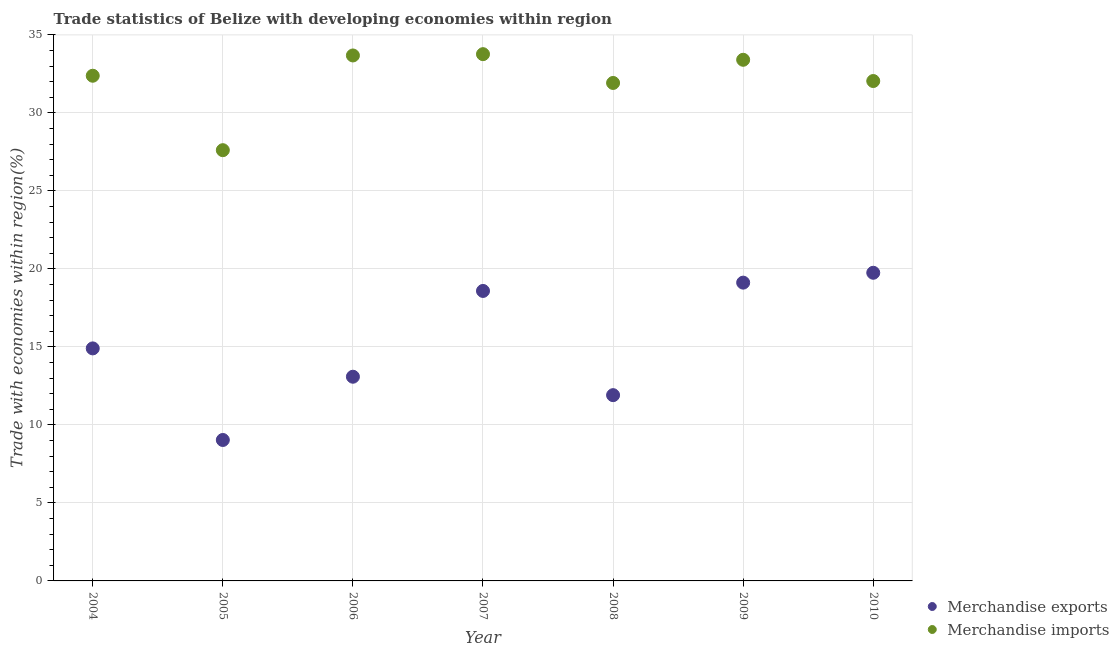What is the merchandise imports in 2009?
Your response must be concise. 33.41. Across all years, what is the maximum merchandise imports?
Provide a succinct answer. 33.77. Across all years, what is the minimum merchandise imports?
Your answer should be compact. 27.61. What is the total merchandise imports in the graph?
Provide a short and direct response. 224.82. What is the difference between the merchandise imports in 2009 and that in 2010?
Your answer should be very brief. 1.36. What is the difference between the merchandise imports in 2007 and the merchandise exports in 2004?
Keep it short and to the point. 18.86. What is the average merchandise exports per year?
Offer a very short reply. 15.2. In the year 2006, what is the difference between the merchandise imports and merchandise exports?
Ensure brevity in your answer.  20.59. In how many years, is the merchandise exports greater than 5 %?
Offer a terse response. 7. What is the ratio of the merchandise exports in 2007 to that in 2010?
Make the answer very short. 0.94. Is the merchandise imports in 2009 less than that in 2010?
Ensure brevity in your answer.  No. Is the difference between the merchandise imports in 2005 and 2007 greater than the difference between the merchandise exports in 2005 and 2007?
Your answer should be very brief. Yes. What is the difference between the highest and the second highest merchandise exports?
Your response must be concise. 0.63. What is the difference between the highest and the lowest merchandise exports?
Your answer should be compact. 10.72. How many dotlines are there?
Offer a terse response. 2. What is the difference between two consecutive major ticks on the Y-axis?
Your response must be concise. 5. Does the graph contain grids?
Keep it short and to the point. Yes. Where does the legend appear in the graph?
Provide a succinct answer. Bottom right. How many legend labels are there?
Your answer should be very brief. 2. How are the legend labels stacked?
Your answer should be compact. Vertical. What is the title of the graph?
Offer a terse response. Trade statistics of Belize with developing economies within region. Does "Death rate" appear as one of the legend labels in the graph?
Your answer should be compact. No. What is the label or title of the X-axis?
Your answer should be very brief. Year. What is the label or title of the Y-axis?
Your answer should be compact. Trade with economies within region(%). What is the Trade with economies within region(%) in Merchandise exports in 2004?
Your answer should be very brief. 14.91. What is the Trade with economies within region(%) in Merchandise imports in 2004?
Make the answer very short. 32.38. What is the Trade with economies within region(%) of Merchandise exports in 2005?
Provide a short and direct response. 9.03. What is the Trade with economies within region(%) in Merchandise imports in 2005?
Keep it short and to the point. 27.61. What is the Trade with economies within region(%) in Merchandise exports in 2006?
Your answer should be compact. 13.09. What is the Trade with economies within region(%) in Merchandise imports in 2006?
Give a very brief answer. 33.68. What is the Trade with economies within region(%) in Merchandise exports in 2007?
Your response must be concise. 18.59. What is the Trade with economies within region(%) in Merchandise imports in 2007?
Give a very brief answer. 33.77. What is the Trade with economies within region(%) of Merchandise exports in 2008?
Ensure brevity in your answer.  11.91. What is the Trade with economies within region(%) of Merchandise imports in 2008?
Offer a very short reply. 31.92. What is the Trade with economies within region(%) of Merchandise exports in 2009?
Offer a very short reply. 19.12. What is the Trade with economies within region(%) of Merchandise imports in 2009?
Ensure brevity in your answer.  33.41. What is the Trade with economies within region(%) in Merchandise exports in 2010?
Ensure brevity in your answer.  19.75. What is the Trade with economies within region(%) of Merchandise imports in 2010?
Your answer should be compact. 32.05. Across all years, what is the maximum Trade with economies within region(%) of Merchandise exports?
Make the answer very short. 19.75. Across all years, what is the maximum Trade with economies within region(%) of Merchandise imports?
Keep it short and to the point. 33.77. Across all years, what is the minimum Trade with economies within region(%) in Merchandise exports?
Offer a very short reply. 9.03. Across all years, what is the minimum Trade with economies within region(%) of Merchandise imports?
Offer a terse response. 27.61. What is the total Trade with economies within region(%) of Merchandise exports in the graph?
Provide a succinct answer. 106.4. What is the total Trade with economies within region(%) in Merchandise imports in the graph?
Provide a succinct answer. 224.82. What is the difference between the Trade with economies within region(%) of Merchandise exports in 2004 and that in 2005?
Keep it short and to the point. 5.87. What is the difference between the Trade with economies within region(%) of Merchandise imports in 2004 and that in 2005?
Give a very brief answer. 4.77. What is the difference between the Trade with economies within region(%) of Merchandise exports in 2004 and that in 2006?
Your response must be concise. 1.82. What is the difference between the Trade with economies within region(%) in Merchandise imports in 2004 and that in 2006?
Provide a short and direct response. -1.3. What is the difference between the Trade with economies within region(%) in Merchandise exports in 2004 and that in 2007?
Make the answer very short. -3.68. What is the difference between the Trade with economies within region(%) of Merchandise imports in 2004 and that in 2007?
Offer a very short reply. -1.38. What is the difference between the Trade with economies within region(%) of Merchandise exports in 2004 and that in 2008?
Your answer should be compact. 3. What is the difference between the Trade with economies within region(%) of Merchandise imports in 2004 and that in 2008?
Offer a very short reply. 0.46. What is the difference between the Trade with economies within region(%) of Merchandise exports in 2004 and that in 2009?
Keep it short and to the point. -4.22. What is the difference between the Trade with economies within region(%) in Merchandise imports in 2004 and that in 2009?
Provide a short and direct response. -1.02. What is the difference between the Trade with economies within region(%) of Merchandise exports in 2004 and that in 2010?
Give a very brief answer. -4.85. What is the difference between the Trade with economies within region(%) in Merchandise imports in 2004 and that in 2010?
Provide a short and direct response. 0.34. What is the difference between the Trade with economies within region(%) of Merchandise exports in 2005 and that in 2006?
Your response must be concise. -4.05. What is the difference between the Trade with economies within region(%) of Merchandise imports in 2005 and that in 2006?
Provide a short and direct response. -6.07. What is the difference between the Trade with economies within region(%) in Merchandise exports in 2005 and that in 2007?
Provide a succinct answer. -9.55. What is the difference between the Trade with economies within region(%) of Merchandise imports in 2005 and that in 2007?
Provide a succinct answer. -6.15. What is the difference between the Trade with economies within region(%) of Merchandise exports in 2005 and that in 2008?
Give a very brief answer. -2.87. What is the difference between the Trade with economies within region(%) in Merchandise imports in 2005 and that in 2008?
Ensure brevity in your answer.  -4.31. What is the difference between the Trade with economies within region(%) of Merchandise exports in 2005 and that in 2009?
Your answer should be compact. -10.09. What is the difference between the Trade with economies within region(%) of Merchandise imports in 2005 and that in 2009?
Keep it short and to the point. -5.79. What is the difference between the Trade with economies within region(%) of Merchandise exports in 2005 and that in 2010?
Provide a succinct answer. -10.72. What is the difference between the Trade with economies within region(%) in Merchandise imports in 2005 and that in 2010?
Give a very brief answer. -4.43. What is the difference between the Trade with economies within region(%) of Merchandise exports in 2006 and that in 2007?
Your response must be concise. -5.5. What is the difference between the Trade with economies within region(%) of Merchandise imports in 2006 and that in 2007?
Your answer should be compact. -0.08. What is the difference between the Trade with economies within region(%) in Merchandise exports in 2006 and that in 2008?
Offer a very short reply. 1.18. What is the difference between the Trade with economies within region(%) of Merchandise imports in 2006 and that in 2008?
Ensure brevity in your answer.  1.76. What is the difference between the Trade with economies within region(%) in Merchandise exports in 2006 and that in 2009?
Provide a short and direct response. -6.03. What is the difference between the Trade with economies within region(%) of Merchandise imports in 2006 and that in 2009?
Give a very brief answer. 0.28. What is the difference between the Trade with economies within region(%) in Merchandise exports in 2006 and that in 2010?
Keep it short and to the point. -6.66. What is the difference between the Trade with economies within region(%) of Merchandise imports in 2006 and that in 2010?
Offer a terse response. 1.64. What is the difference between the Trade with economies within region(%) in Merchandise exports in 2007 and that in 2008?
Your answer should be very brief. 6.68. What is the difference between the Trade with economies within region(%) in Merchandise imports in 2007 and that in 2008?
Offer a terse response. 1.85. What is the difference between the Trade with economies within region(%) of Merchandise exports in 2007 and that in 2009?
Your response must be concise. -0.53. What is the difference between the Trade with economies within region(%) of Merchandise imports in 2007 and that in 2009?
Your answer should be very brief. 0.36. What is the difference between the Trade with economies within region(%) in Merchandise exports in 2007 and that in 2010?
Give a very brief answer. -1.16. What is the difference between the Trade with economies within region(%) of Merchandise imports in 2007 and that in 2010?
Your answer should be compact. 1.72. What is the difference between the Trade with economies within region(%) in Merchandise exports in 2008 and that in 2009?
Keep it short and to the point. -7.21. What is the difference between the Trade with economies within region(%) in Merchandise imports in 2008 and that in 2009?
Your answer should be very brief. -1.49. What is the difference between the Trade with economies within region(%) of Merchandise exports in 2008 and that in 2010?
Provide a succinct answer. -7.84. What is the difference between the Trade with economies within region(%) in Merchandise imports in 2008 and that in 2010?
Give a very brief answer. -0.12. What is the difference between the Trade with economies within region(%) in Merchandise exports in 2009 and that in 2010?
Keep it short and to the point. -0.63. What is the difference between the Trade with economies within region(%) in Merchandise imports in 2009 and that in 2010?
Your answer should be compact. 1.36. What is the difference between the Trade with economies within region(%) in Merchandise exports in 2004 and the Trade with economies within region(%) in Merchandise imports in 2005?
Your answer should be very brief. -12.71. What is the difference between the Trade with economies within region(%) in Merchandise exports in 2004 and the Trade with economies within region(%) in Merchandise imports in 2006?
Keep it short and to the point. -18.78. What is the difference between the Trade with economies within region(%) of Merchandise exports in 2004 and the Trade with economies within region(%) of Merchandise imports in 2007?
Offer a terse response. -18.86. What is the difference between the Trade with economies within region(%) in Merchandise exports in 2004 and the Trade with economies within region(%) in Merchandise imports in 2008?
Provide a short and direct response. -17.02. What is the difference between the Trade with economies within region(%) in Merchandise exports in 2004 and the Trade with economies within region(%) in Merchandise imports in 2009?
Ensure brevity in your answer.  -18.5. What is the difference between the Trade with economies within region(%) in Merchandise exports in 2004 and the Trade with economies within region(%) in Merchandise imports in 2010?
Make the answer very short. -17.14. What is the difference between the Trade with economies within region(%) of Merchandise exports in 2005 and the Trade with economies within region(%) of Merchandise imports in 2006?
Your answer should be compact. -24.65. What is the difference between the Trade with economies within region(%) in Merchandise exports in 2005 and the Trade with economies within region(%) in Merchandise imports in 2007?
Provide a succinct answer. -24.73. What is the difference between the Trade with economies within region(%) of Merchandise exports in 2005 and the Trade with economies within region(%) of Merchandise imports in 2008?
Your response must be concise. -22.89. What is the difference between the Trade with economies within region(%) in Merchandise exports in 2005 and the Trade with economies within region(%) in Merchandise imports in 2009?
Provide a short and direct response. -24.37. What is the difference between the Trade with economies within region(%) of Merchandise exports in 2005 and the Trade with economies within region(%) of Merchandise imports in 2010?
Keep it short and to the point. -23.01. What is the difference between the Trade with economies within region(%) in Merchandise exports in 2006 and the Trade with economies within region(%) in Merchandise imports in 2007?
Offer a very short reply. -20.68. What is the difference between the Trade with economies within region(%) of Merchandise exports in 2006 and the Trade with economies within region(%) of Merchandise imports in 2008?
Provide a succinct answer. -18.83. What is the difference between the Trade with economies within region(%) of Merchandise exports in 2006 and the Trade with economies within region(%) of Merchandise imports in 2009?
Keep it short and to the point. -20.32. What is the difference between the Trade with economies within region(%) in Merchandise exports in 2006 and the Trade with economies within region(%) in Merchandise imports in 2010?
Give a very brief answer. -18.96. What is the difference between the Trade with economies within region(%) of Merchandise exports in 2007 and the Trade with economies within region(%) of Merchandise imports in 2008?
Ensure brevity in your answer.  -13.33. What is the difference between the Trade with economies within region(%) in Merchandise exports in 2007 and the Trade with economies within region(%) in Merchandise imports in 2009?
Your response must be concise. -14.82. What is the difference between the Trade with economies within region(%) in Merchandise exports in 2007 and the Trade with economies within region(%) in Merchandise imports in 2010?
Ensure brevity in your answer.  -13.46. What is the difference between the Trade with economies within region(%) in Merchandise exports in 2008 and the Trade with economies within region(%) in Merchandise imports in 2009?
Keep it short and to the point. -21.5. What is the difference between the Trade with economies within region(%) in Merchandise exports in 2008 and the Trade with economies within region(%) in Merchandise imports in 2010?
Your response must be concise. -20.14. What is the difference between the Trade with economies within region(%) in Merchandise exports in 2009 and the Trade with economies within region(%) in Merchandise imports in 2010?
Your answer should be very brief. -12.92. What is the average Trade with economies within region(%) of Merchandise exports per year?
Keep it short and to the point. 15.2. What is the average Trade with economies within region(%) in Merchandise imports per year?
Provide a short and direct response. 32.12. In the year 2004, what is the difference between the Trade with economies within region(%) in Merchandise exports and Trade with economies within region(%) in Merchandise imports?
Your answer should be compact. -17.48. In the year 2005, what is the difference between the Trade with economies within region(%) in Merchandise exports and Trade with economies within region(%) in Merchandise imports?
Provide a short and direct response. -18.58. In the year 2006, what is the difference between the Trade with economies within region(%) in Merchandise exports and Trade with economies within region(%) in Merchandise imports?
Your response must be concise. -20.59. In the year 2007, what is the difference between the Trade with economies within region(%) in Merchandise exports and Trade with economies within region(%) in Merchandise imports?
Your answer should be very brief. -15.18. In the year 2008, what is the difference between the Trade with economies within region(%) of Merchandise exports and Trade with economies within region(%) of Merchandise imports?
Keep it short and to the point. -20.01. In the year 2009, what is the difference between the Trade with economies within region(%) in Merchandise exports and Trade with economies within region(%) in Merchandise imports?
Your answer should be compact. -14.29. In the year 2010, what is the difference between the Trade with economies within region(%) of Merchandise exports and Trade with economies within region(%) of Merchandise imports?
Ensure brevity in your answer.  -12.29. What is the ratio of the Trade with economies within region(%) of Merchandise exports in 2004 to that in 2005?
Provide a short and direct response. 1.65. What is the ratio of the Trade with economies within region(%) in Merchandise imports in 2004 to that in 2005?
Offer a terse response. 1.17. What is the ratio of the Trade with economies within region(%) of Merchandise exports in 2004 to that in 2006?
Offer a terse response. 1.14. What is the ratio of the Trade with economies within region(%) of Merchandise imports in 2004 to that in 2006?
Provide a short and direct response. 0.96. What is the ratio of the Trade with economies within region(%) of Merchandise exports in 2004 to that in 2007?
Provide a succinct answer. 0.8. What is the ratio of the Trade with economies within region(%) in Merchandise imports in 2004 to that in 2007?
Provide a short and direct response. 0.96. What is the ratio of the Trade with economies within region(%) in Merchandise exports in 2004 to that in 2008?
Your answer should be compact. 1.25. What is the ratio of the Trade with economies within region(%) of Merchandise imports in 2004 to that in 2008?
Provide a short and direct response. 1.01. What is the ratio of the Trade with economies within region(%) of Merchandise exports in 2004 to that in 2009?
Your response must be concise. 0.78. What is the ratio of the Trade with economies within region(%) in Merchandise imports in 2004 to that in 2009?
Give a very brief answer. 0.97. What is the ratio of the Trade with economies within region(%) of Merchandise exports in 2004 to that in 2010?
Your answer should be very brief. 0.75. What is the ratio of the Trade with economies within region(%) in Merchandise imports in 2004 to that in 2010?
Provide a succinct answer. 1.01. What is the ratio of the Trade with economies within region(%) of Merchandise exports in 2005 to that in 2006?
Give a very brief answer. 0.69. What is the ratio of the Trade with economies within region(%) of Merchandise imports in 2005 to that in 2006?
Your answer should be very brief. 0.82. What is the ratio of the Trade with economies within region(%) of Merchandise exports in 2005 to that in 2007?
Make the answer very short. 0.49. What is the ratio of the Trade with economies within region(%) in Merchandise imports in 2005 to that in 2007?
Provide a succinct answer. 0.82. What is the ratio of the Trade with economies within region(%) of Merchandise exports in 2005 to that in 2008?
Offer a terse response. 0.76. What is the ratio of the Trade with economies within region(%) of Merchandise imports in 2005 to that in 2008?
Your answer should be compact. 0.86. What is the ratio of the Trade with economies within region(%) in Merchandise exports in 2005 to that in 2009?
Your response must be concise. 0.47. What is the ratio of the Trade with economies within region(%) of Merchandise imports in 2005 to that in 2009?
Your response must be concise. 0.83. What is the ratio of the Trade with economies within region(%) in Merchandise exports in 2005 to that in 2010?
Your response must be concise. 0.46. What is the ratio of the Trade with economies within region(%) in Merchandise imports in 2005 to that in 2010?
Your answer should be very brief. 0.86. What is the ratio of the Trade with economies within region(%) in Merchandise exports in 2006 to that in 2007?
Keep it short and to the point. 0.7. What is the ratio of the Trade with economies within region(%) in Merchandise imports in 2006 to that in 2007?
Offer a terse response. 1. What is the ratio of the Trade with economies within region(%) in Merchandise exports in 2006 to that in 2008?
Your response must be concise. 1.1. What is the ratio of the Trade with economies within region(%) of Merchandise imports in 2006 to that in 2008?
Your response must be concise. 1.06. What is the ratio of the Trade with economies within region(%) in Merchandise exports in 2006 to that in 2009?
Your answer should be very brief. 0.68. What is the ratio of the Trade with economies within region(%) in Merchandise imports in 2006 to that in 2009?
Give a very brief answer. 1.01. What is the ratio of the Trade with economies within region(%) in Merchandise exports in 2006 to that in 2010?
Your answer should be very brief. 0.66. What is the ratio of the Trade with economies within region(%) of Merchandise imports in 2006 to that in 2010?
Ensure brevity in your answer.  1.05. What is the ratio of the Trade with economies within region(%) in Merchandise exports in 2007 to that in 2008?
Your answer should be very brief. 1.56. What is the ratio of the Trade with economies within region(%) of Merchandise imports in 2007 to that in 2008?
Your answer should be very brief. 1.06. What is the ratio of the Trade with economies within region(%) in Merchandise exports in 2007 to that in 2009?
Offer a terse response. 0.97. What is the ratio of the Trade with economies within region(%) of Merchandise imports in 2007 to that in 2009?
Offer a very short reply. 1.01. What is the ratio of the Trade with economies within region(%) of Merchandise exports in 2007 to that in 2010?
Your answer should be very brief. 0.94. What is the ratio of the Trade with economies within region(%) of Merchandise imports in 2007 to that in 2010?
Give a very brief answer. 1.05. What is the ratio of the Trade with economies within region(%) in Merchandise exports in 2008 to that in 2009?
Ensure brevity in your answer.  0.62. What is the ratio of the Trade with economies within region(%) of Merchandise imports in 2008 to that in 2009?
Your answer should be compact. 0.96. What is the ratio of the Trade with economies within region(%) in Merchandise exports in 2008 to that in 2010?
Your answer should be very brief. 0.6. What is the ratio of the Trade with economies within region(%) of Merchandise imports in 2009 to that in 2010?
Your answer should be compact. 1.04. What is the difference between the highest and the second highest Trade with economies within region(%) of Merchandise exports?
Your response must be concise. 0.63. What is the difference between the highest and the second highest Trade with economies within region(%) of Merchandise imports?
Ensure brevity in your answer.  0.08. What is the difference between the highest and the lowest Trade with economies within region(%) of Merchandise exports?
Make the answer very short. 10.72. What is the difference between the highest and the lowest Trade with economies within region(%) in Merchandise imports?
Your answer should be very brief. 6.15. 